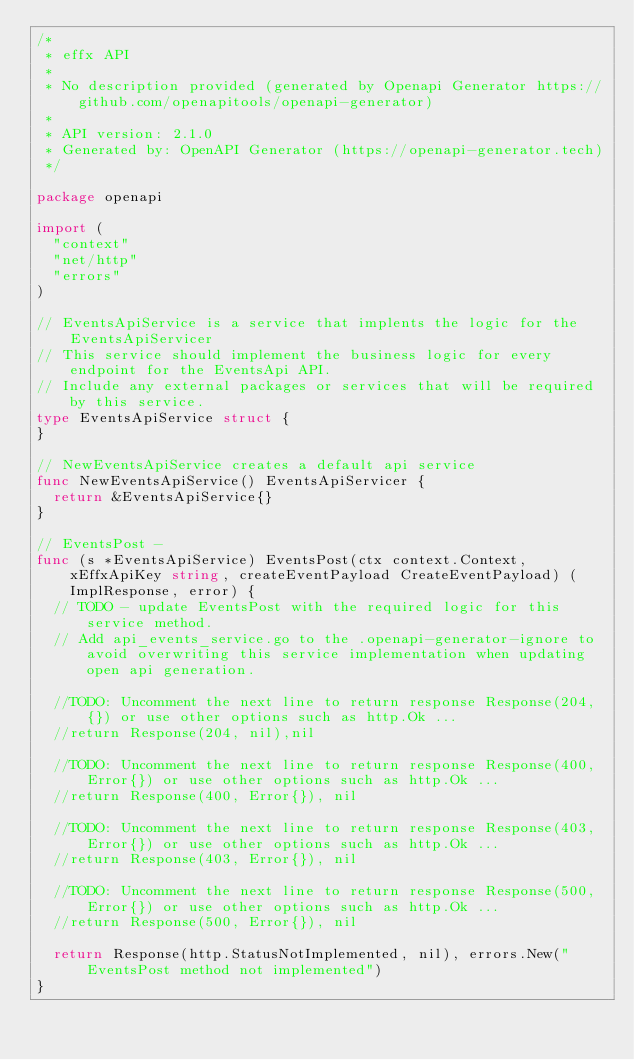Convert code to text. <code><loc_0><loc_0><loc_500><loc_500><_Go_>/*
 * effx API
 *
 * No description provided (generated by Openapi Generator https://github.com/openapitools/openapi-generator)
 *
 * API version: 2.1.0
 * Generated by: OpenAPI Generator (https://openapi-generator.tech)
 */

package openapi

import (
	"context"
	"net/http"
	"errors"
)

// EventsApiService is a service that implents the logic for the EventsApiServicer
// This service should implement the business logic for every endpoint for the EventsApi API. 
// Include any external packages or services that will be required by this service.
type EventsApiService struct {
}

// NewEventsApiService creates a default api service
func NewEventsApiService() EventsApiServicer {
	return &EventsApiService{}
}

// EventsPost - 
func (s *EventsApiService) EventsPost(ctx context.Context, xEffxApiKey string, createEventPayload CreateEventPayload) (ImplResponse, error) {
	// TODO - update EventsPost with the required logic for this service method.
	// Add api_events_service.go to the .openapi-generator-ignore to avoid overwriting this service implementation when updating open api generation.

	//TODO: Uncomment the next line to return response Response(204, {}) or use other options such as http.Ok ...
	//return Response(204, nil),nil

	//TODO: Uncomment the next line to return response Response(400, Error{}) or use other options such as http.Ok ...
	//return Response(400, Error{}), nil

	//TODO: Uncomment the next line to return response Response(403, Error{}) or use other options such as http.Ok ...
	//return Response(403, Error{}), nil

	//TODO: Uncomment the next line to return response Response(500, Error{}) or use other options such as http.Ok ...
	//return Response(500, Error{}), nil

	return Response(http.StatusNotImplemented, nil), errors.New("EventsPost method not implemented")
}

</code> 